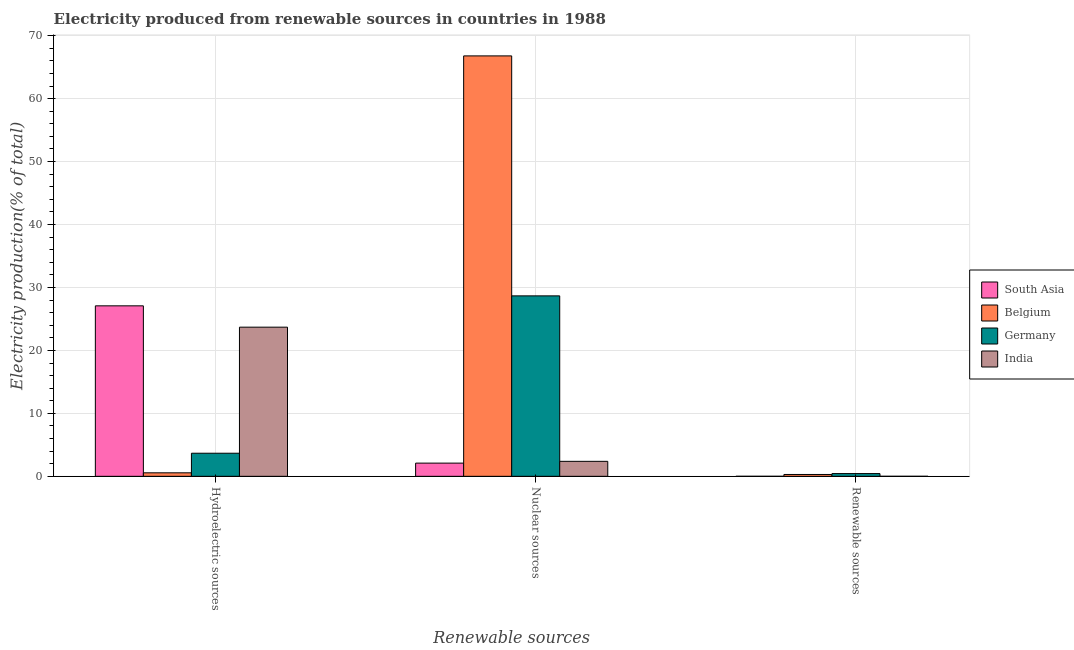How many groups of bars are there?
Your response must be concise. 3. How many bars are there on the 1st tick from the left?
Make the answer very short. 4. What is the label of the 3rd group of bars from the left?
Your response must be concise. Renewable sources. What is the percentage of electricity produced by renewable sources in Belgium?
Your answer should be compact. 0.29. Across all countries, what is the maximum percentage of electricity produced by nuclear sources?
Ensure brevity in your answer.  66.78. Across all countries, what is the minimum percentage of electricity produced by hydroelectric sources?
Ensure brevity in your answer.  0.56. In which country was the percentage of electricity produced by hydroelectric sources minimum?
Your answer should be compact. Belgium. What is the total percentage of electricity produced by renewable sources in the graph?
Your response must be concise. 0.73. What is the difference between the percentage of electricity produced by hydroelectric sources in Germany and that in Belgium?
Your answer should be compact. 3.11. What is the difference between the percentage of electricity produced by renewable sources in Germany and the percentage of electricity produced by hydroelectric sources in South Asia?
Make the answer very short. -26.65. What is the average percentage of electricity produced by renewable sources per country?
Your answer should be compact. 0.18. What is the difference between the percentage of electricity produced by hydroelectric sources and percentage of electricity produced by nuclear sources in Germany?
Offer a very short reply. -25. What is the ratio of the percentage of electricity produced by hydroelectric sources in Germany to that in India?
Your answer should be very brief. 0.15. Is the difference between the percentage of electricity produced by nuclear sources in South Asia and Belgium greater than the difference between the percentage of electricity produced by renewable sources in South Asia and Belgium?
Make the answer very short. No. What is the difference between the highest and the second highest percentage of electricity produced by renewable sources?
Your answer should be very brief. 0.14. What is the difference between the highest and the lowest percentage of electricity produced by nuclear sources?
Make the answer very short. 64.69. Is the sum of the percentage of electricity produced by nuclear sources in Germany and India greater than the maximum percentage of electricity produced by hydroelectric sources across all countries?
Your answer should be very brief. Yes. Are the values on the major ticks of Y-axis written in scientific E-notation?
Your answer should be very brief. No. Does the graph contain grids?
Your answer should be compact. Yes. How many legend labels are there?
Give a very brief answer. 4. What is the title of the graph?
Your response must be concise. Electricity produced from renewable sources in countries in 1988. What is the label or title of the X-axis?
Offer a terse response. Renewable sources. What is the Electricity production(% of total) in South Asia in Hydroelectric sources?
Ensure brevity in your answer.  27.08. What is the Electricity production(% of total) in Belgium in Hydroelectric sources?
Keep it short and to the point. 0.56. What is the Electricity production(% of total) in Germany in Hydroelectric sources?
Give a very brief answer. 3.67. What is the Electricity production(% of total) of India in Hydroelectric sources?
Your answer should be compact. 23.69. What is the Electricity production(% of total) of South Asia in Nuclear sources?
Your response must be concise. 2.1. What is the Electricity production(% of total) of Belgium in Nuclear sources?
Make the answer very short. 66.78. What is the Electricity production(% of total) in Germany in Nuclear sources?
Give a very brief answer. 28.66. What is the Electricity production(% of total) in India in Nuclear sources?
Your answer should be very brief. 2.38. What is the Electricity production(% of total) in South Asia in Renewable sources?
Provide a short and direct response. 0. What is the Electricity production(% of total) of Belgium in Renewable sources?
Give a very brief answer. 0.29. What is the Electricity production(% of total) in Germany in Renewable sources?
Your answer should be compact. 0.43. What is the Electricity production(% of total) in India in Renewable sources?
Offer a very short reply. 0. Across all Renewable sources, what is the maximum Electricity production(% of total) of South Asia?
Give a very brief answer. 27.08. Across all Renewable sources, what is the maximum Electricity production(% of total) in Belgium?
Ensure brevity in your answer.  66.78. Across all Renewable sources, what is the maximum Electricity production(% of total) in Germany?
Your answer should be compact. 28.66. Across all Renewable sources, what is the maximum Electricity production(% of total) of India?
Your answer should be very brief. 23.69. Across all Renewable sources, what is the minimum Electricity production(% of total) in South Asia?
Offer a terse response. 0. Across all Renewable sources, what is the minimum Electricity production(% of total) in Belgium?
Ensure brevity in your answer.  0.29. Across all Renewable sources, what is the minimum Electricity production(% of total) of Germany?
Keep it short and to the point. 0.43. Across all Renewable sources, what is the minimum Electricity production(% of total) in India?
Your answer should be very brief. 0. What is the total Electricity production(% of total) of South Asia in the graph?
Offer a terse response. 29.18. What is the total Electricity production(% of total) in Belgium in the graph?
Provide a short and direct response. 67.63. What is the total Electricity production(% of total) in Germany in the graph?
Offer a very short reply. 32.77. What is the total Electricity production(% of total) of India in the graph?
Your answer should be very brief. 26.08. What is the difference between the Electricity production(% of total) of South Asia in Hydroelectric sources and that in Nuclear sources?
Your answer should be compact. 24.98. What is the difference between the Electricity production(% of total) in Belgium in Hydroelectric sources and that in Nuclear sources?
Make the answer very short. -66.23. What is the difference between the Electricity production(% of total) in Germany in Hydroelectric sources and that in Nuclear sources?
Keep it short and to the point. -25. What is the difference between the Electricity production(% of total) of India in Hydroelectric sources and that in Nuclear sources?
Provide a short and direct response. 21.31. What is the difference between the Electricity production(% of total) in South Asia in Hydroelectric sources and that in Renewable sources?
Provide a short and direct response. 27.08. What is the difference between the Electricity production(% of total) in Belgium in Hydroelectric sources and that in Renewable sources?
Offer a terse response. 0.26. What is the difference between the Electricity production(% of total) in Germany in Hydroelectric sources and that in Renewable sources?
Make the answer very short. 3.23. What is the difference between the Electricity production(% of total) of India in Hydroelectric sources and that in Renewable sources?
Your answer should be compact. 23.69. What is the difference between the Electricity production(% of total) in South Asia in Nuclear sources and that in Renewable sources?
Your response must be concise. 2.09. What is the difference between the Electricity production(% of total) of Belgium in Nuclear sources and that in Renewable sources?
Offer a very short reply. 66.49. What is the difference between the Electricity production(% of total) of Germany in Nuclear sources and that in Renewable sources?
Offer a terse response. 28.23. What is the difference between the Electricity production(% of total) of India in Nuclear sources and that in Renewable sources?
Ensure brevity in your answer.  2.38. What is the difference between the Electricity production(% of total) in South Asia in Hydroelectric sources and the Electricity production(% of total) in Belgium in Nuclear sources?
Provide a succinct answer. -39.7. What is the difference between the Electricity production(% of total) of South Asia in Hydroelectric sources and the Electricity production(% of total) of Germany in Nuclear sources?
Give a very brief answer. -1.58. What is the difference between the Electricity production(% of total) in South Asia in Hydroelectric sources and the Electricity production(% of total) in India in Nuclear sources?
Offer a very short reply. 24.7. What is the difference between the Electricity production(% of total) of Belgium in Hydroelectric sources and the Electricity production(% of total) of Germany in Nuclear sources?
Provide a succinct answer. -28.11. What is the difference between the Electricity production(% of total) of Belgium in Hydroelectric sources and the Electricity production(% of total) of India in Nuclear sources?
Ensure brevity in your answer.  -1.82. What is the difference between the Electricity production(% of total) of Germany in Hydroelectric sources and the Electricity production(% of total) of India in Nuclear sources?
Provide a short and direct response. 1.29. What is the difference between the Electricity production(% of total) of South Asia in Hydroelectric sources and the Electricity production(% of total) of Belgium in Renewable sources?
Offer a very short reply. 26.79. What is the difference between the Electricity production(% of total) in South Asia in Hydroelectric sources and the Electricity production(% of total) in Germany in Renewable sources?
Keep it short and to the point. 26.65. What is the difference between the Electricity production(% of total) in South Asia in Hydroelectric sources and the Electricity production(% of total) in India in Renewable sources?
Ensure brevity in your answer.  27.08. What is the difference between the Electricity production(% of total) in Belgium in Hydroelectric sources and the Electricity production(% of total) in Germany in Renewable sources?
Offer a very short reply. 0.12. What is the difference between the Electricity production(% of total) in Belgium in Hydroelectric sources and the Electricity production(% of total) in India in Renewable sources?
Offer a terse response. 0.55. What is the difference between the Electricity production(% of total) of Germany in Hydroelectric sources and the Electricity production(% of total) of India in Renewable sources?
Provide a short and direct response. 3.67. What is the difference between the Electricity production(% of total) in South Asia in Nuclear sources and the Electricity production(% of total) in Belgium in Renewable sources?
Keep it short and to the point. 1.81. What is the difference between the Electricity production(% of total) in South Asia in Nuclear sources and the Electricity production(% of total) in Germany in Renewable sources?
Your response must be concise. 1.66. What is the difference between the Electricity production(% of total) in South Asia in Nuclear sources and the Electricity production(% of total) in India in Renewable sources?
Keep it short and to the point. 2.09. What is the difference between the Electricity production(% of total) in Belgium in Nuclear sources and the Electricity production(% of total) in Germany in Renewable sources?
Provide a succinct answer. 66.35. What is the difference between the Electricity production(% of total) in Belgium in Nuclear sources and the Electricity production(% of total) in India in Renewable sources?
Give a very brief answer. 66.78. What is the difference between the Electricity production(% of total) of Germany in Nuclear sources and the Electricity production(% of total) of India in Renewable sources?
Keep it short and to the point. 28.66. What is the average Electricity production(% of total) of South Asia per Renewable sources?
Provide a succinct answer. 9.73. What is the average Electricity production(% of total) of Belgium per Renewable sources?
Offer a very short reply. 22.54. What is the average Electricity production(% of total) in Germany per Renewable sources?
Offer a very short reply. 10.92. What is the average Electricity production(% of total) of India per Renewable sources?
Your answer should be compact. 8.69. What is the difference between the Electricity production(% of total) of South Asia and Electricity production(% of total) of Belgium in Hydroelectric sources?
Your response must be concise. 26.53. What is the difference between the Electricity production(% of total) in South Asia and Electricity production(% of total) in Germany in Hydroelectric sources?
Provide a succinct answer. 23.41. What is the difference between the Electricity production(% of total) of South Asia and Electricity production(% of total) of India in Hydroelectric sources?
Ensure brevity in your answer.  3.39. What is the difference between the Electricity production(% of total) of Belgium and Electricity production(% of total) of Germany in Hydroelectric sources?
Give a very brief answer. -3.11. What is the difference between the Electricity production(% of total) in Belgium and Electricity production(% of total) in India in Hydroelectric sources?
Give a very brief answer. -23.14. What is the difference between the Electricity production(% of total) in Germany and Electricity production(% of total) in India in Hydroelectric sources?
Your answer should be very brief. -20.02. What is the difference between the Electricity production(% of total) of South Asia and Electricity production(% of total) of Belgium in Nuclear sources?
Provide a short and direct response. -64.69. What is the difference between the Electricity production(% of total) of South Asia and Electricity production(% of total) of Germany in Nuclear sources?
Provide a succinct answer. -26.57. What is the difference between the Electricity production(% of total) in South Asia and Electricity production(% of total) in India in Nuclear sources?
Your response must be concise. -0.28. What is the difference between the Electricity production(% of total) of Belgium and Electricity production(% of total) of Germany in Nuclear sources?
Your answer should be very brief. 38.12. What is the difference between the Electricity production(% of total) of Belgium and Electricity production(% of total) of India in Nuclear sources?
Keep it short and to the point. 64.4. What is the difference between the Electricity production(% of total) of Germany and Electricity production(% of total) of India in Nuclear sources?
Make the answer very short. 26.28. What is the difference between the Electricity production(% of total) in South Asia and Electricity production(% of total) in Belgium in Renewable sources?
Give a very brief answer. -0.29. What is the difference between the Electricity production(% of total) in South Asia and Electricity production(% of total) in Germany in Renewable sources?
Offer a very short reply. -0.43. What is the difference between the Electricity production(% of total) in South Asia and Electricity production(% of total) in India in Renewable sources?
Provide a short and direct response. -0. What is the difference between the Electricity production(% of total) of Belgium and Electricity production(% of total) of Germany in Renewable sources?
Provide a succinct answer. -0.14. What is the difference between the Electricity production(% of total) of Belgium and Electricity production(% of total) of India in Renewable sources?
Your answer should be very brief. 0.29. What is the difference between the Electricity production(% of total) in Germany and Electricity production(% of total) in India in Renewable sources?
Provide a short and direct response. 0.43. What is the ratio of the Electricity production(% of total) in South Asia in Hydroelectric sources to that in Nuclear sources?
Provide a succinct answer. 12.92. What is the ratio of the Electricity production(% of total) in Belgium in Hydroelectric sources to that in Nuclear sources?
Your response must be concise. 0.01. What is the ratio of the Electricity production(% of total) in Germany in Hydroelectric sources to that in Nuclear sources?
Ensure brevity in your answer.  0.13. What is the ratio of the Electricity production(% of total) in India in Hydroelectric sources to that in Nuclear sources?
Keep it short and to the point. 9.95. What is the ratio of the Electricity production(% of total) of South Asia in Hydroelectric sources to that in Renewable sources?
Ensure brevity in your answer.  1.31e+04. What is the ratio of the Electricity production(% of total) of Belgium in Hydroelectric sources to that in Renewable sources?
Your answer should be very brief. 1.91. What is the ratio of the Electricity production(% of total) in Germany in Hydroelectric sources to that in Renewable sources?
Keep it short and to the point. 8.44. What is the ratio of the Electricity production(% of total) of India in Hydroelectric sources to that in Renewable sources?
Make the answer very short. 9647.33. What is the ratio of the Electricity production(% of total) in South Asia in Nuclear sources to that in Renewable sources?
Keep it short and to the point. 1011.83. What is the ratio of the Electricity production(% of total) of Belgium in Nuclear sources to that in Renewable sources?
Keep it short and to the point. 229.27. What is the ratio of the Electricity production(% of total) in Germany in Nuclear sources to that in Renewable sources?
Give a very brief answer. 66. What is the ratio of the Electricity production(% of total) in India in Nuclear sources to that in Renewable sources?
Your answer should be very brief. 969.5. What is the difference between the highest and the second highest Electricity production(% of total) of South Asia?
Provide a short and direct response. 24.98. What is the difference between the highest and the second highest Electricity production(% of total) of Belgium?
Offer a very short reply. 66.23. What is the difference between the highest and the second highest Electricity production(% of total) of Germany?
Offer a very short reply. 25. What is the difference between the highest and the second highest Electricity production(% of total) in India?
Your answer should be compact. 21.31. What is the difference between the highest and the lowest Electricity production(% of total) of South Asia?
Ensure brevity in your answer.  27.08. What is the difference between the highest and the lowest Electricity production(% of total) in Belgium?
Ensure brevity in your answer.  66.49. What is the difference between the highest and the lowest Electricity production(% of total) of Germany?
Offer a terse response. 28.23. What is the difference between the highest and the lowest Electricity production(% of total) of India?
Keep it short and to the point. 23.69. 